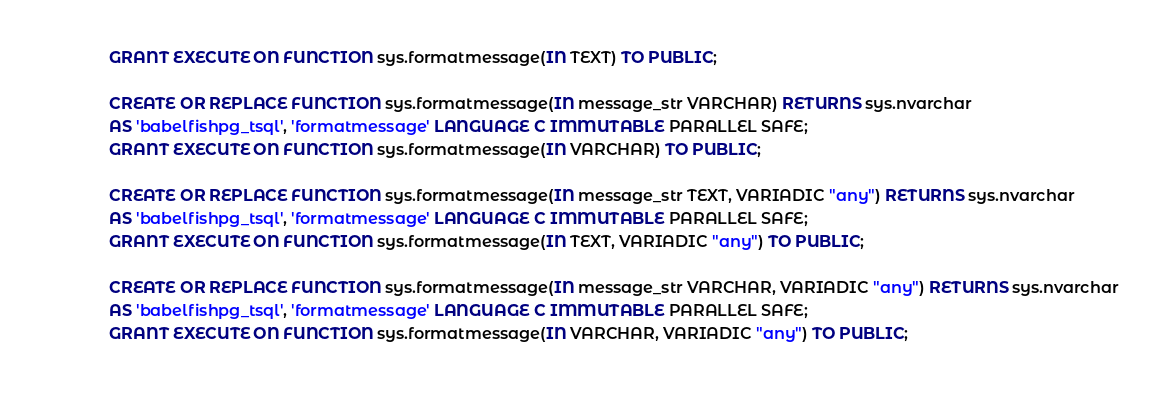Convert code to text. <code><loc_0><loc_0><loc_500><loc_500><_SQL_>GRANT EXECUTE ON FUNCTION sys.formatmessage(IN TEXT) TO PUBLIC;

CREATE OR REPLACE FUNCTION sys.formatmessage(IN message_str VARCHAR) RETURNS sys.nvarchar
AS 'babelfishpg_tsql', 'formatmessage' LANGUAGE C IMMUTABLE PARALLEL SAFE;
GRANT EXECUTE ON FUNCTION sys.formatmessage(IN VARCHAR) TO PUBLIC;

CREATE OR REPLACE FUNCTION sys.formatmessage(IN message_str TEXT, VARIADIC "any") RETURNS sys.nvarchar
AS 'babelfishpg_tsql', 'formatmessage' LANGUAGE C IMMUTABLE PARALLEL SAFE;
GRANT EXECUTE ON FUNCTION sys.formatmessage(IN TEXT, VARIADIC "any") TO PUBLIC; 

CREATE OR REPLACE FUNCTION sys.formatmessage(IN message_str VARCHAR, VARIADIC "any") RETURNS sys.nvarchar
AS 'babelfishpg_tsql', 'formatmessage' LANGUAGE C IMMUTABLE PARALLEL SAFE;
GRANT EXECUTE ON FUNCTION sys.formatmessage(IN VARCHAR, VARIADIC "any") TO PUBLIC;
</code> 